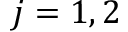<formula> <loc_0><loc_0><loc_500><loc_500>j = 1 , 2</formula> 